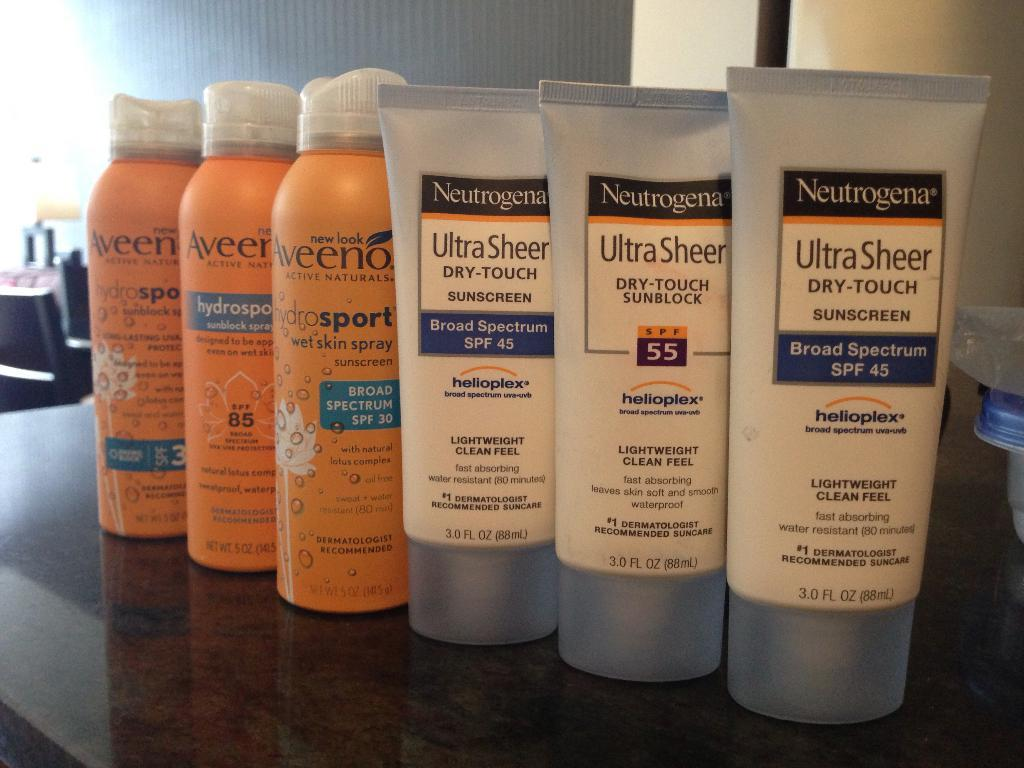<image>
Offer a succinct explanation of the picture presented. Bottles of Neutrogena and Aveeno sunscreen are lined up. 